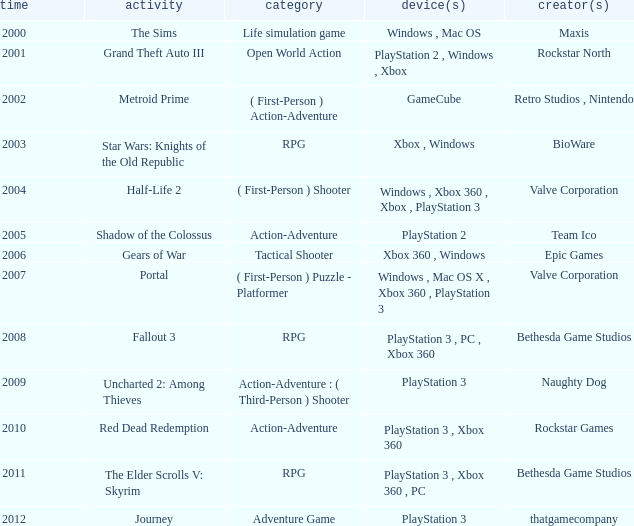Can you parse all the data within this table? {'header': ['time', 'activity', 'category', 'device(s)', 'creator(s)'], 'rows': [['2000', 'The Sims', 'Life simulation game', 'Windows , Mac OS', 'Maxis'], ['2001', 'Grand Theft Auto III', 'Open World Action', 'PlayStation 2 , Windows , Xbox', 'Rockstar North'], ['2002', 'Metroid Prime', '( First-Person ) Action-Adventure', 'GameCube', 'Retro Studios , Nintendo'], ['2003', 'Star Wars: Knights of the Old Republic', 'RPG', 'Xbox , Windows', 'BioWare'], ['2004', 'Half-Life 2', '( First-Person ) Shooter', 'Windows , Xbox 360 , Xbox , PlayStation 3', 'Valve Corporation'], ['2005', 'Shadow of the Colossus', 'Action-Adventure', 'PlayStation 2', 'Team Ico'], ['2006', 'Gears of War', 'Tactical Shooter', 'Xbox 360 , Windows', 'Epic Games'], ['2007', 'Portal', '( First-Person ) Puzzle - Platformer', 'Windows , Mac OS X , Xbox 360 , PlayStation 3', 'Valve Corporation'], ['2008', 'Fallout 3', 'RPG', 'PlayStation 3 , PC , Xbox 360', 'Bethesda Game Studios'], ['2009', 'Uncharted 2: Among Thieves', 'Action-Adventure : ( Third-Person ) Shooter', 'PlayStation 3', 'Naughty Dog'], ['2010', 'Red Dead Redemption', 'Action-Adventure', 'PlayStation 3 , Xbox 360', 'Rockstar Games'], ['2011', 'The Elder Scrolls V: Skyrim', 'RPG', 'PlayStation 3 , Xbox 360 , PC', 'Bethesda Game Studios'], ['2012', 'Journey', 'Adventure Game', 'PlayStation 3', 'thatgamecompany']]} What's the genre of The Sims before 2002? Life simulation game. 